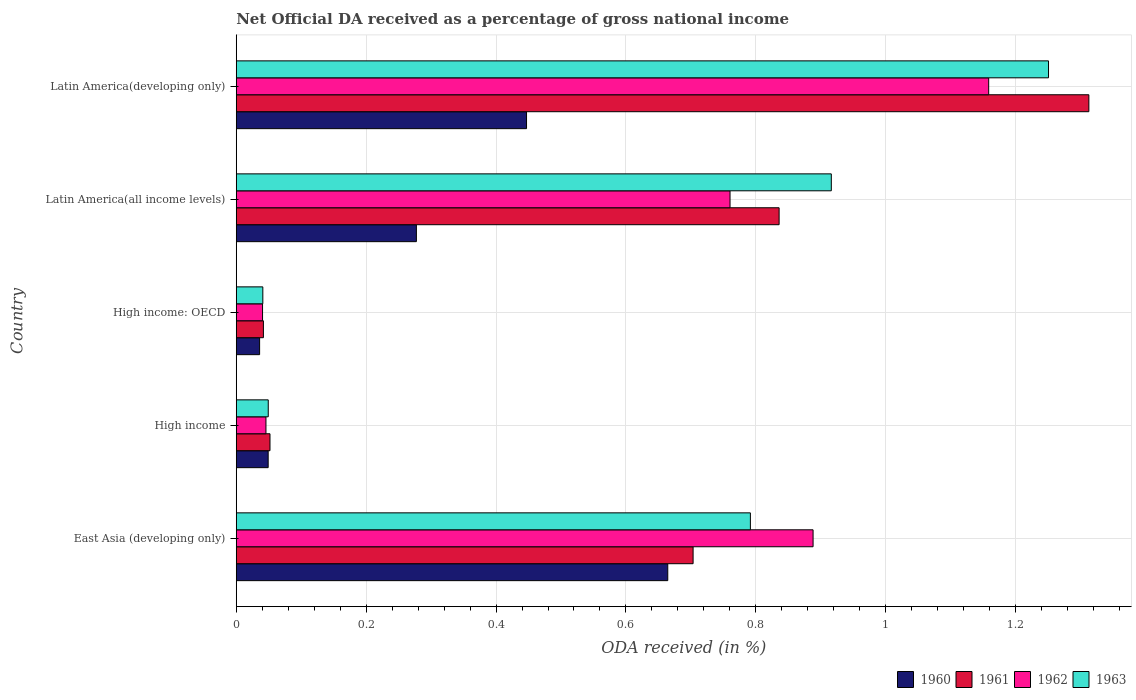Are the number of bars per tick equal to the number of legend labels?
Offer a very short reply. Yes. How many bars are there on the 1st tick from the top?
Your answer should be very brief. 4. How many bars are there on the 5th tick from the bottom?
Give a very brief answer. 4. What is the net official DA received in 1963 in Latin America(all income levels)?
Your answer should be very brief. 0.92. Across all countries, what is the maximum net official DA received in 1960?
Provide a succinct answer. 0.66. Across all countries, what is the minimum net official DA received in 1962?
Make the answer very short. 0.04. In which country was the net official DA received in 1960 maximum?
Your answer should be very brief. East Asia (developing only). In which country was the net official DA received in 1961 minimum?
Offer a terse response. High income: OECD. What is the total net official DA received in 1962 in the graph?
Make the answer very short. 2.89. What is the difference between the net official DA received in 1963 in High income and that in High income: OECD?
Offer a terse response. 0.01. What is the difference between the net official DA received in 1962 in Latin America(all income levels) and the net official DA received in 1960 in High income: OECD?
Make the answer very short. 0.72. What is the average net official DA received in 1962 per country?
Your answer should be very brief. 0.58. What is the difference between the net official DA received in 1963 and net official DA received in 1962 in High income?
Keep it short and to the point. 0. What is the ratio of the net official DA received in 1961 in East Asia (developing only) to that in Latin America(developing only)?
Offer a very short reply. 0.54. Is the net official DA received in 1960 in East Asia (developing only) less than that in High income?
Keep it short and to the point. No. What is the difference between the highest and the second highest net official DA received in 1960?
Ensure brevity in your answer.  0.22. What is the difference between the highest and the lowest net official DA received in 1962?
Ensure brevity in your answer.  1.12. Is it the case that in every country, the sum of the net official DA received in 1961 and net official DA received in 1963 is greater than the sum of net official DA received in 1960 and net official DA received in 1962?
Your answer should be compact. No. What does the 3rd bar from the bottom in High income: OECD represents?
Provide a succinct answer. 1962. How many countries are there in the graph?
Ensure brevity in your answer.  5. What is the difference between two consecutive major ticks on the X-axis?
Your answer should be compact. 0.2. Does the graph contain any zero values?
Give a very brief answer. No. Does the graph contain grids?
Make the answer very short. Yes. Where does the legend appear in the graph?
Your response must be concise. Bottom right. How many legend labels are there?
Your answer should be very brief. 4. How are the legend labels stacked?
Your answer should be very brief. Horizontal. What is the title of the graph?
Keep it short and to the point. Net Official DA received as a percentage of gross national income. Does "2009" appear as one of the legend labels in the graph?
Your answer should be very brief. No. What is the label or title of the X-axis?
Keep it short and to the point. ODA received (in %). What is the ODA received (in %) of 1960 in East Asia (developing only)?
Make the answer very short. 0.66. What is the ODA received (in %) in 1961 in East Asia (developing only)?
Your response must be concise. 0.7. What is the ODA received (in %) in 1962 in East Asia (developing only)?
Your response must be concise. 0.89. What is the ODA received (in %) of 1963 in East Asia (developing only)?
Give a very brief answer. 0.79. What is the ODA received (in %) of 1960 in High income?
Keep it short and to the point. 0.05. What is the ODA received (in %) of 1961 in High income?
Offer a terse response. 0.05. What is the ODA received (in %) of 1962 in High income?
Give a very brief answer. 0.05. What is the ODA received (in %) in 1963 in High income?
Give a very brief answer. 0.05. What is the ODA received (in %) in 1960 in High income: OECD?
Provide a short and direct response. 0.04. What is the ODA received (in %) of 1961 in High income: OECD?
Give a very brief answer. 0.04. What is the ODA received (in %) of 1962 in High income: OECD?
Offer a terse response. 0.04. What is the ODA received (in %) of 1963 in High income: OECD?
Provide a succinct answer. 0.04. What is the ODA received (in %) of 1960 in Latin America(all income levels)?
Provide a succinct answer. 0.28. What is the ODA received (in %) in 1961 in Latin America(all income levels)?
Ensure brevity in your answer.  0.84. What is the ODA received (in %) in 1962 in Latin America(all income levels)?
Offer a very short reply. 0.76. What is the ODA received (in %) in 1963 in Latin America(all income levels)?
Offer a terse response. 0.92. What is the ODA received (in %) of 1960 in Latin America(developing only)?
Provide a short and direct response. 0.45. What is the ODA received (in %) in 1961 in Latin America(developing only)?
Keep it short and to the point. 1.31. What is the ODA received (in %) of 1962 in Latin America(developing only)?
Your answer should be compact. 1.16. What is the ODA received (in %) of 1963 in Latin America(developing only)?
Ensure brevity in your answer.  1.25. Across all countries, what is the maximum ODA received (in %) in 1960?
Ensure brevity in your answer.  0.66. Across all countries, what is the maximum ODA received (in %) in 1961?
Provide a succinct answer. 1.31. Across all countries, what is the maximum ODA received (in %) of 1962?
Provide a short and direct response. 1.16. Across all countries, what is the maximum ODA received (in %) in 1963?
Provide a succinct answer. 1.25. Across all countries, what is the minimum ODA received (in %) of 1960?
Your answer should be very brief. 0.04. Across all countries, what is the minimum ODA received (in %) of 1961?
Offer a very short reply. 0.04. Across all countries, what is the minimum ODA received (in %) of 1962?
Ensure brevity in your answer.  0.04. Across all countries, what is the minimum ODA received (in %) of 1963?
Make the answer very short. 0.04. What is the total ODA received (in %) in 1960 in the graph?
Your response must be concise. 1.47. What is the total ODA received (in %) in 1961 in the graph?
Ensure brevity in your answer.  2.95. What is the total ODA received (in %) in 1962 in the graph?
Your answer should be very brief. 2.89. What is the total ODA received (in %) in 1963 in the graph?
Keep it short and to the point. 3.05. What is the difference between the ODA received (in %) in 1960 in East Asia (developing only) and that in High income?
Provide a short and direct response. 0.62. What is the difference between the ODA received (in %) in 1961 in East Asia (developing only) and that in High income?
Your answer should be compact. 0.65. What is the difference between the ODA received (in %) in 1962 in East Asia (developing only) and that in High income?
Your answer should be compact. 0.84. What is the difference between the ODA received (in %) in 1963 in East Asia (developing only) and that in High income?
Your response must be concise. 0.74. What is the difference between the ODA received (in %) in 1960 in East Asia (developing only) and that in High income: OECD?
Give a very brief answer. 0.63. What is the difference between the ODA received (in %) of 1961 in East Asia (developing only) and that in High income: OECD?
Make the answer very short. 0.66. What is the difference between the ODA received (in %) in 1962 in East Asia (developing only) and that in High income: OECD?
Keep it short and to the point. 0.85. What is the difference between the ODA received (in %) in 1963 in East Asia (developing only) and that in High income: OECD?
Your answer should be compact. 0.75. What is the difference between the ODA received (in %) of 1960 in East Asia (developing only) and that in Latin America(all income levels)?
Offer a terse response. 0.39. What is the difference between the ODA received (in %) of 1961 in East Asia (developing only) and that in Latin America(all income levels)?
Provide a short and direct response. -0.13. What is the difference between the ODA received (in %) in 1962 in East Asia (developing only) and that in Latin America(all income levels)?
Provide a short and direct response. 0.13. What is the difference between the ODA received (in %) in 1963 in East Asia (developing only) and that in Latin America(all income levels)?
Provide a succinct answer. -0.12. What is the difference between the ODA received (in %) in 1960 in East Asia (developing only) and that in Latin America(developing only)?
Keep it short and to the point. 0.22. What is the difference between the ODA received (in %) of 1961 in East Asia (developing only) and that in Latin America(developing only)?
Offer a very short reply. -0.61. What is the difference between the ODA received (in %) of 1962 in East Asia (developing only) and that in Latin America(developing only)?
Keep it short and to the point. -0.27. What is the difference between the ODA received (in %) of 1963 in East Asia (developing only) and that in Latin America(developing only)?
Offer a very short reply. -0.46. What is the difference between the ODA received (in %) of 1960 in High income and that in High income: OECD?
Provide a succinct answer. 0.01. What is the difference between the ODA received (in %) in 1961 in High income and that in High income: OECD?
Offer a very short reply. 0.01. What is the difference between the ODA received (in %) of 1962 in High income and that in High income: OECD?
Your response must be concise. 0.01. What is the difference between the ODA received (in %) in 1963 in High income and that in High income: OECD?
Your answer should be very brief. 0.01. What is the difference between the ODA received (in %) in 1960 in High income and that in Latin America(all income levels)?
Offer a terse response. -0.23. What is the difference between the ODA received (in %) in 1961 in High income and that in Latin America(all income levels)?
Offer a terse response. -0.78. What is the difference between the ODA received (in %) in 1962 in High income and that in Latin America(all income levels)?
Keep it short and to the point. -0.71. What is the difference between the ODA received (in %) in 1963 in High income and that in Latin America(all income levels)?
Make the answer very short. -0.87. What is the difference between the ODA received (in %) of 1960 in High income and that in Latin America(developing only)?
Offer a very short reply. -0.4. What is the difference between the ODA received (in %) in 1961 in High income and that in Latin America(developing only)?
Ensure brevity in your answer.  -1.26. What is the difference between the ODA received (in %) in 1962 in High income and that in Latin America(developing only)?
Give a very brief answer. -1.11. What is the difference between the ODA received (in %) of 1963 in High income and that in Latin America(developing only)?
Give a very brief answer. -1.2. What is the difference between the ODA received (in %) in 1960 in High income: OECD and that in Latin America(all income levels)?
Offer a very short reply. -0.24. What is the difference between the ODA received (in %) of 1961 in High income: OECD and that in Latin America(all income levels)?
Keep it short and to the point. -0.79. What is the difference between the ODA received (in %) in 1962 in High income: OECD and that in Latin America(all income levels)?
Your answer should be compact. -0.72. What is the difference between the ODA received (in %) of 1963 in High income: OECD and that in Latin America(all income levels)?
Keep it short and to the point. -0.88. What is the difference between the ODA received (in %) in 1960 in High income: OECD and that in Latin America(developing only)?
Make the answer very short. -0.41. What is the difference between the ODA received (in %) of 1961 in High income: OECD and that in Latin America(developing only)?
Ensure brevity in your answer.  -1.27. What is the difference between the ODA received (in %) in 1962 in High income: OECD and that in Latin America(developing only)?
Your response must be concise. -1.12. What is the difference between the ODA received (in %) of 1963 in High income: OECD and that in Latin America(developing only)?
Provide a short and direct response. -1.21. What is the difference between the ODA received (in %) in 1960 in Latin America(all income levels) and that in Latin America(developing only)?
Make the answer very short. -0.17. What is the difference between the ODA received (in %) of 1961 in Latin America(all income levels) and that in Latin America(developing only)?
Your answer should be compact. -0.48. What is the difference between the ODA received (in %) of 1962 in Latin America(all income levels) and that in Latin America(developing only)?
Provide a short and direct response. -0.4. What is the difference between the ODA received (in %) of 1963 in Latin America(all income levels) and that in Latin America(developing only)?
Make the answer very short. -0.33. What is the difference between the ODA received (in %) of 1960 in East Asia (developing only) and the ODA received (in %) of 1961 in High income?
Keep it short and to the point. 0.61. What is the difference between the ODA received (in %) of 1960 in East Asia (developing only) and the ODA received (in %) of 1962 in High income?
Provide a succinct answer. 0.62. What is the difference between the ODA received (in %) in 1960 in East Asia (developing only) and the ODA received (in %) in 1963 in High income?
Provide a succinct answer. 0.62. What is the difference between the ODA received (in %) of 1961 in East Asia (developing only) and the ODA received (in %) of 1962 in High income?
Offer a terse response. 0.66. What is the difference between the ODA received (in %) in 1961 in East Asia (developing only) and the ODA received (in %) in 1963 in High income?
Your response must be concise. 0.65. What is the difference between the ODA received (in %) in 1962 in East Asia (developing only) and the ODA received (in %) in 1963 in High income?
Provide a succinct answer. 0.84. What is the difference between the ODA received (in %) of 1960 in East Asia (developing only) and the ODA received (in %) of 1961 in High income: OECD?
Give a very brief answer. 0.62. What is the difference between the ODA received (in %) in 1960 in East Asia (developing only) and the ODA received (in %) in 1962 in High income: OECD?
Provide a short and direct response. 0.62. What is the difference between the ODA received (in %) in 1960 in East Asia (developing only) and the ODA received (in %) in 1963 in High income: OECD?
Provide a succinct answer. 0.62. What is the difference between the ODA received (in %) in 1961 in East Asia (developing only) and the ODA received (in %) in 1962 in High income: OECD?
Your response must be concise. 0.66. What is the difference between the ODA received (in %) of 1961 in East Asia (developing only) and the ODA received (in %) of 1963 in High income: OECD?
Your answer should be compact. 0.66. What is the difference between the ODA received (in %) of 1962 in East Asia (developing only) and the ODA received (in %) of 1963 in High income: OECD?
Your response must be concise. 0.85. What is the difference between the ODA received (in %) in 1960 in East Asia (developing only) and the ODA received (in %) in 1961 in Latin America(all income levels)?
Give a very brief answer. -0.17. What is the difference between the ODA received (in %) in 1960 in East Asia (developing only) and the ODA received (in %) in 1962 in Latin America(all income levels)?
Offer a very short reply. -0.1. What is the difference between the ODA received (in %) in 1960 in East Asia (developing only) and the ODA received (in %) in 1963 in Latin America(all income levels)?
Provide a short and direct response. -0.25. What is the difference between the ODA received (in %) in 1961 in East Asia (developing only) and the ODA received (in %) in 1962 in Latin America(all income levels)?
Your response must be concise. -0.06. What is the difference between the ODA received (in %) of 1961 in East Asia (developing only) and the ODA received (in %) of 1963 in Latin America(all income levels)?
Your answer should be very brief. -0.21. What is the difference between the ODA received (in %) in 1962 in East Asia (developing only) and the ODA received (in %) in 1963 in Latin America(all income levels)?
Your answer should be very brief. -0.03. What is the difference between the ODA received (in %) of 1960 in East Asia (developing only) and the ODA received (in %) of 1961 in Latin America(developing only)?
Ensure brevity in your answer.  -0.65. What is the difference between the ODA received (in %) in 1960 in East Asia (developing only) and the ODA received (in %) in 1962 in Latin America(developing only)?
Make the answer very short. -0.49. What is the difference between the ODA received (in %) of 1960 in East Asia (developing only) and the ODA received (in %) of 1963 in Latin America(developing only)?
Offer a terse response. -0.59. What is the difference between the ODA received (in %) in 1961 in East Asia (developing only) and the ODA received (in %) in 1962 in Latin America(developing only)?
Provide a succinct answer. -0.46. What is the difference between the ODA received (in %) of 1961 in East Asia (developing only) and the ODA received (in %) of 1963 in Latin America(developing only)?
Provide a succinct answer. -0.55. What is the difference between the ODA received (in %) in 1962 in East Asia (developing only) and the ODA received (in %) in 1963 in Latin America(developing only)?
Ensure brevity in your answer.  -0.36. What is the difference between the ODA received (in %) of 1960 in High income and the ODA received (in %) of 1961 in High income: OECD?
Your response must be concise. 0.01. What is the difference between the ODA received (in %) of 1960 in High income and the ODA received (in %) of 1962 in High income: OECD?
Your response must be concise. 0.01. What is the difference between the ODA received (in %) of 1960 in High income and the ODA received (in %) of 1963 in High income: OECD?
Make the answer very short. 0.01. What is the difference between the ODA received (in %) of 1961 in High income and the ODA received (in %) of 1962 in High income: OECD?
Offer a very short reply. 0.01. What is the difference between the ODA received (in %) of 1961 in High income and the ODA received (in %) of 1963 in High income: OECD?
Provide a succinct answer. 0.01. What is the difference between the ODA received (in %) of 1962 in High income and the ODA received (in %) of 1963 in High income: OECD?
Provide a short and direct response. 0. What is the difference between the ODA received (in %) of 1960 in High income and the ODA received (in %) of 1961 in Latin America(all income levels)?
Ensure brevity in your answer.  -0.79. What is the difference between the ODA received (in %) in 1960 in High income and the ODA received (in %) in 1962 in Latin America(all income levels)?
Offer a terse response. -0.71. What is the difference between the ODA received (in %) of 1960 in High income and the ODA received (in %) of 1963 in Latin America(all income levels)?
Your answer should be compact. -0.87. What is the difference between the ODA received (in %) in 1961 in High income and the ODA received (in %) in 1962 in Latin America(all income levels)?
Your answer should be compact. -0.71. What is the difference between the ODA received (in %) of 1961 in High income and the ODA received (in %) of 1963 in Latin America(all income levels)?
Your response must be concise. -0.86. What is the difference between the ODA received (in %) in 1962 in High income and the ODA received (in %) in 1963 in Latin America(all income levels)?
Your response must be concise. -0.87. What is the difference between the ODA received (in %) in 1960 in High income and the ODA received (in %) in 1961 in Latin America(developing only)?
Keep it short and to the point. -1.26. What is the difference between the ODA received (in %) in 1960 in High income and the ODA received (in %) in 1962 in Latin America(developing only)?
Make the answer very short. -1.11. What is the difference between the ODA received (in %) of 1960 in High income and the ODA received (in %) of 1963 in Latin America(developing only)?
Provide a short and direct response. -1.2. What is the difference between the ODA received (in %) of 1961 in High income and the ODA received (in %) of 1962 in Latin America(developing only)?
Provide a succinct answer. -1.11. What is the difference between the ODA received (in %) of 1961 in High income and the ODA received (in %) of 1963 in Latin America(developing only)?
Make the answer very short. -1.2. What is the difference between the ODA received (in %) in 1962 in High income and the ODA received (in %) in 1963 in Latin America(developing only)?
Your response must be concise. -1.2. What is the difference between the ODA received (in %) of 1960 in High income: OECD and the ODA received (in %) of 1961 in Latin America(all income levels)?
Offer a very short reply. -0.8. What is the difference between the ODA received (in %) of 1960 in High income: OECD and the ODA received (in %) of 1962 in Latin America(all income levels)?
Offer a very short reply. -0.72. What is the difference between the ODA received (in %) in 1960 in High income: OECD and the ODA received (in %) in 1963 in Latin America(all income levels)?
Make the answer very short. -0.88. What is the difference between the ODA received (in %) in 1961 in High income: OECD and the ODA received (in %) in 1962 in Latin America(all income levels)?
Offer a very short reply. -0.72. What is the difference between the ODA received (in %) of 1961 in High income: OECD and the ODA received (in %) of 1963 in Latin America(all income levels)?
Keep it short and to the point. -0.87. What is the difference between the ODA received (in %) of 1962 in High income: OECD and the ODA received (in %) of 1963 in Latin America(all income levels)?
Provide a succinct answer. -0.88. What is the difference between the ODA received (in %) of 1960 in High income: OECD and the ODA received (in %) of 1961 in Latin America(developing only)?
Your answer should be very brief. -1.28. What is the difference between the ODA received (in %) of 1960 in High income: OECD and the ODA received (in %) of 1962 in Latin America(developing only)?
Give a very brief answer. -1.12. What is the difference between the ODA received (in %) in 1960 in High income: OECD and the ODA received (in %) in 1963 in Latin America(developing only)?
Ensure brevity in your answer.  -1.21. What is the difference between the ODA received (in %) of 1961 in High income: OECD and the ODA received (in %) of 1962 in Latin America(developing only)?
Your response must be concise. -1.12. What is the difference between the ODA received (in %) in 1961 in High income: OECD and the ODA received (in %) in 1963 in Latin America(developing only)?
Offer a very short reply. -1.21. What is the difference between the ODA received (in %) of 1962 in High income: OECD and the ODA received (in %) of 1963 in Latin America(developing only)?
Provide a succinct answer. -1.21. What is the difference between the ODA received (in %) in 1960 in Latin America(all income levels) and the ODA received (in %) in 1961 in Latin America(developing only)?
Your answer should be very brief. -1.04. What is the difference between the ODA received (in %) in 1960 in Latin America(all income levels) and the ODA received (in %) in 1962 in Latin America(developing only)?
Give a very brief answer. -0.88. What is the difference between the ODA received (in %) of 1960 in Latin America(all income levels) and the ODA received (in %) of 1963 in Latin America(developing only)?
Give a very brief answer. -0.97. What is the difference between the ODA received (in %) of 1961 in Latin America(all income levels) and the ODA received (in %) of 1962 in Latin America(developing only)?
Ensure brevity in your answer.  -0.32. What is the difference between the ODA received (in %) of 1961 in Latin America(all income levels) and the ODA received (in %) of 1963 in Latin America(developing only)?
Give a very brief answer. -0.41. What is the difference between the ODA received (in %) of 1962 in Latin America(all income levels) and the ODA received (in %) of 1963 in Latin America(developing only)?
Provide a short and direct response. -0.49. What is the average ODA received (in %) in 1960 per country?
Your response must be concise. 0.29. What is the average ODA received (in %) in 1961 per country?
Your response must be concise. 0.59. What is the average ODA received (in %) in 1962 per country?
Your response must be concise. 0.58. What is the average ODA received (in %) of 1963 per country?
Give a very brief answer. 0.61. What is the difference between the ODA received (in %) of 1960 and ODA received (in %) of 1961 in East Asia (developing only)?
Offer a terse response. -0.04. What is the difference between the ODA received (in %) of 1960 and ODA received (in %) of 1962 in East Asia (developing only)?
Offer a very short reply. -0.22. What is the difference between the ODA received (in %) in 1960 and ODA received (in %) in 1963 in East Asia (developing only)?
Your answer should be very brief. -0.13. What is the difference between the ODA received (in %) in 1961 and ODA received (in %) in 1962 in East Asia (developing only)?
Provide a short and direct response. -0.18. What is the difference between the ODA received (in %) in 1961 and ODA received (in %) in 1963 in East Asia (developing only)?
Offer a terse response. -0.09. What is the difference between the ODA received (in %) of 1962 and ODA received (in %) of 1963 in East Asia (developing only)?
Ensure brevity in your answer.  0.1. What is the difference between the ODA received (in %) in 1960 and ODA received (in %) in 1961 in High income?
Make the answer very short. -0. What is the difference between the ODA received (in %) of 1960 and ODA received (in %) of 1962 in High income?
Your response must be concise. 0. What is the difference between the ODA received (in %) in 1960 and ODA received (in %) in 1963 in High income?
Provide a succinct answer. -0. What is the difference between the ODA received (in %) of 1961 and ODA received (in %) of 1962 in High income?
Your response must be concise. 0.01. What is the difference between the ODA received (in %) in 1961 and ODA received (in %) in 1963 in High income?
Your answer should be very brief. 0. What is the difference between the ODA received (in %) of 1962 and ODA received (in %) of 1963 in High income?
Make the answer very short. -0. What is the difference between the ODA received (in %) in 1960 and ODA received (in %) in 1961 in High income: OECD?
Your response must be concise. -0.01. What is the difference between the ODA received (in %) of 1960 and ODA received (in %) of 1962 in High income: OECD?
Make the answer very short. -0. What is the difference between the ODA received (in %) of 1960 and ODA received (in %) of 1963 in High income: OECD?
Ensure brevity in your answer.  -0.01. What is the difference between the ODA received (in %) of 1961 and ODA received (in %) of 1962 in High income: OECD?
Offer a terse response. 0. What is the difference between the ODA received (in %) in 1961 and ODA received (in %) in 1963 in High income: OECD?
Make the answer very short. 0. What is the difference between the ODA received (in %) of 1962 and ODA received (in %) of 1963 in High income: OECD?
Ensure brevity in your answer.  -0. What is the difference between the ODA received (in %) in 1960 and ODA received (in %) in 1961 in Latin America(all income levels)?
Ensure brevity in your answer.  -0.56. What is the difference between the ODA received (in %) in 1960 and ODA received (in %) in 1962 in Latin America(all income levels)?
Offer a terse response. -0.48. What is the difference between the ODA received (in %) of 1960 and ODA received (in %) of 1963 in Latin America(all income levels)?
Ensure brevity in your answer.  -0.64. What is the difference between the ODA received (in %) in 1961 and ODA received (in %) in 1962 in Latin America(all income levels)?
Provide a short and direct response. 0.08. What is the difference between the ODA received (in %) in 1961 and ODA received (in %) in 1963 in Latin America(all income levels)?
Your response must be concise. -0.08. What is the difference between the ODA received (in %) of 1962 and ODA received (in %) of 1963 in Latin America(all income levels)?
Offer a terse response. -0.16. What is the difference between the ODA received (in %) of 1960 and ODA received (in %) of 1961 in Latin America(developing only)?
Give a very brief answer. -0.87. What is the difference between the ODA received (in %) of 1960 and ODA received (in %) of 1962 in Latin America(developing only)?
Make the answer very short. -0.71. What is the difference between the ODA received (in %) in 1960 and ODA received (in %) in 1963 in Latin America(developing only)?
Offer a very short reply. -0.8. What is the difference between the ODA received (in %) in 1961 and ODA received (in %) in 1962 in Latin America(developing only)?
Your answer should be compact. 0.15. What is the difference between the ODA received (in %) in 1961 and ODA received (in %) in 1963 in Latin America(developing only)?
Your answer should be compact. 0.06. What is the difference between the ODA received (in %) in 1962 and ODA received (in %) in 1963 in Latin America(developing only)?
Your answer should be very brief. -0.09. What is the ratio of the ODA received (in %) of 1960 in East Asia (developing only) to that in High income?
Your answer should be compact. 13.52. What is the ratio of the ODA received (in %) in 1961 in East Asia (developing only) to that in High income?
Your answer should be compact. 13.54. What is the ratio of the ODA received (in %) in 1962 in East Asia (developing only) to that in High income?
Keep it short and to the point. 19.42. What is the ratio of the ODA received (in %) in 1963 in East Asia (developing only) to that in High income?
Your answer should be compact. 16.07. What is the ratio of the ODA received (in %) in 1960 in East Asia (developing only) to that in High income: OECD?
Keep it short and to the point. 18.48. What is the ratio of the ODA received (in %) of 1961 in East Asia (developing only) to that in High income: OECD?
Offer a very short reply. 16.83. What is the ratio of the ODA received (in %) of 1962 in East Asia (developing only) to that in High income: OECD?
Your answer should be very brief. 21.93. What is the ratio of the ODA received (in %) in 1963 in East Asia (developing only) to that in High income: OECD?
Offer a terse response. 19.34. What is the ratio of the ODA received (in %) of 1960 in East Asia (developing only) to that in Latin America(all income levels)?
Provide a succinct answer. 2.4. What is the ratio of the ODA received (in %) in 1961 in East Asia (developing only) to that in Latin America(all income levels)?
Keep it short and to the point. 0.84. What is the ratio of the ODA received (in %) of 1962 in East Asia (developing only) to that in Latin America(all income levels)?
Offer a terse response. 1.17. What is the ratio of the ODA received (in %) of 1963 in East Asia (developing only) to that in Latin America(all income levels)?
Keep it short and to the point. 0.86. What is the ratio of the ODA received (in %) of 1960 in East Asia (developing only) to that in Latin America(developing only)?
Make the answer very short. 1.49. What is the ratio of the ODA received (in %) in 1961 in East Asia (developing only) to that in Latin America(developing only)?
Your answer should be very brief. 0.54. What is the ratio of the ODA received (in %) of 1962 in East Asia (developing only) to that in Latin America(developing only)?
Make the answer very short. 0.77. What is the ratio of the ODA received (in %) in 1963 in East Asia (developing only) to that in Latin America(developing only)?
Give a very brief answer. 0.63. What is the ratio of the ODA received (in %) in 1960 in High income to that in High income: OECD?
Provide a short and direct response. 1.37. What is the ratio of the ODA received (in %) in 1961 in High income to that in High income: OECD?
Provide a succinct answer. 1.24. What is the ratio of the ODA received (in %) in 1962 in High income to that in High income: OECD?
Offer a terse response. 1.13. What is the ratio of the ODA received (in %) in 1963 in High income to that in High income: OECD?
Your answer should be compact. 1.2. What is the ratio of the ODA received (in %) in 1960 in High income to that in Latin America(all income levels)?
Give a very brief answer. 0.18. What is the ratio of the ODA received (in %) in 1961 in High income to that in Latin America(all income levels)?
Ensure brevity in your answer.  0.06. What is the ratio of the ODA received (in %) in 1962 in High income to that in Latin America(all income levels)?
Give a very brief answer. 0.06. What is the ratio of the ODA received (in %) in 1963 in High income to that in Latin America(all income levels)?
Ensure brevity in your answer.  0.05. What is the ratio of the ODA received (in %) in 1960 in High income to that in Latin America(developing only)?
Offer a very short reply. 0.11. What is the ratio of the ODA received (in %) of 1961 in High income to that in Latin America(developing only)?
Your answer should be very brief. 0.04. What is the ratio of the ODA received (in %) of 1962 in High income to that in Latin America(developing only)?
Your answer should be very brief. 0.04. What is the ratio of the ODA received (in %) in 1963 in High income to that in Latin America(developing only)?
Offer a very short reply. 0.04. What is the ratio of the ODA received (in %) in 1960 in High income: OECD to that in Latin America(all income levels)?
Ensure brevity in your answer.  0.13. What is the ratio of the ODA received (in %) of 1962 in High income: OECD to that in Latin America(all income levels)?
Give a very brief answer. 0.05. What is the ratio of the ODA received (in %) of 1963 in High income: OECD to that in Latin America(all income levels)?
Keep it short and to the point. 0.04. What is the ratio of the ODA received (in %) in 1960 in High income: OECD to that in Latin America(developing only)?
Make the answer very short. 0.08. What is the ratio of the ODA received (in %) in 1961 in High income: OECD to that in Latin America(developing only)?
Provide a short and direct response. 0.03. What is the ratio of the ODA received (in %) of 1962 in High income: OECD to that in Latin America(developing only)?
Provide a short and direct response. 0.04. What is the ratio of the ODA received (in %) in 1963 in High income: OECD to that in Latin America(developing only)?
Offer a terse response. 0.03. What is the ratio of the ODA received (in %) of 1960 in Latin America(all income levels) to that in Latin America(developing only)?
Your answer should be compact. 0.62. What is the ratio of the ODA received (in %) in 1961 in Latin America(all income levels) to that in Latin America(developing only)?
Make the answer very short. 0.64. What is the ratio of the ODA received (in %) in 1962 in Latin America(all income levels) to that in Latin America(developing only)?
Make the answer very short. 0.66. What is the ratio of the ODA received (in %) of 1963 in Latin America(all income levels) to that in Latin America(developing only)?
Keep it short and to the point. 0.73. What is the difference between the highest and the second highest ODA received (in %) in 1960?
Offer a very short reply. 0.22. What is the difference between the highest and the second highest ODA received (in %) of 1961?
Give a very brief answer. 0.48. What is the difference between the highest and the second highest ODA received (in %) of 1962?
Offer a very short reply. 0.27. What is the difference between the highest and the second highest ODA received (in %) of 1963?
Give a very brief answer. 0.33. What is the difference between the highest and the lowest ODA received (in %) of 1960?
Keep it short and to the point. 0.63. What is the difference between the highest and the lowest ODA received (in %) of 1961?
Your response must be concise. 1.27. What is the difference between the highest and the lowest ODA received (in %) of 1962?
Offer a very short reply. 1.12. What is the difference between the highest and the lowest ODA received (in %) in 1963?
Offer a terse response. 1.21. 